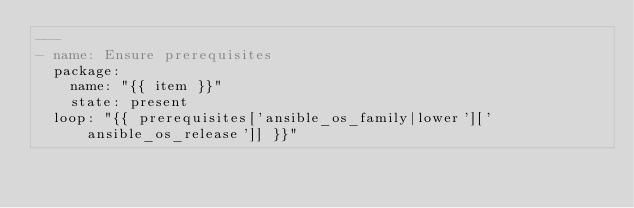Convert code to text. <code><loc_0><loc_0><loc_500><loc_500><_YAML_>---
- name: Ensure prerequisites
  package:
    name: "{{ item }}"
    state: present
  loop: "{{ prerequisites['ansible_os_family|lower']['ansible_os_release']] }}"</code> 